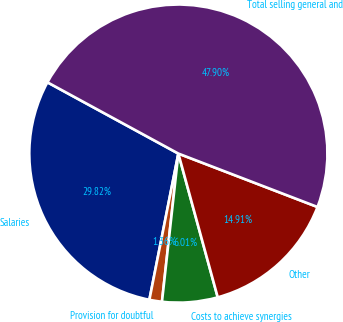<chart> <loc_0><loc_0><loc_500><loc_500><pie_chart><fcel>Salaries<fcel>Provision for doubtful<fcel>Costs to achieve synergies<fcel>Other<fcel>Total selling general and<nl><fcel>29.82%<fcel>1.36%<fcel>6.01%<fcel>14.91%<fcel>47.9%<nl></chart> 